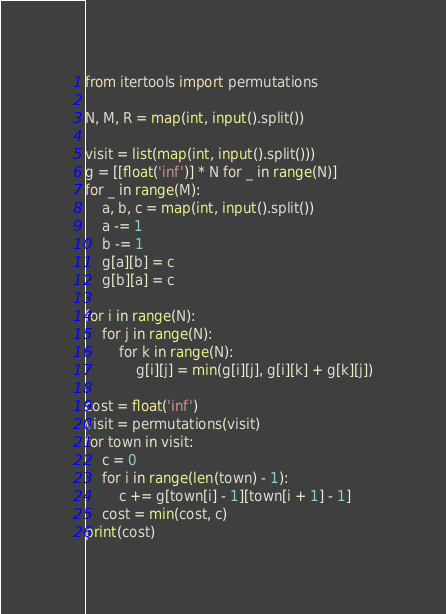<code> <loc_0><loc_0><loc_500><loc_500><_Python_>from itertools import permutations

N, M, R = map(int, input().split())

visit = list(map(int, input().split()))
g = [[float('inf')] * N for _ in range(N)]
for _ in range(M):
    a, b, c = map(int, input().split())
    a -= 1
    b -= 1
    g[a][b] = c
    g[b][a] = c

for i in range(N):
    for j in range(N):
        for k in range(N):
            g[i][j] = min(g[i][j], g[i][k] + g[k][j])

cost = float('inf')
visit = permutations(visit)
for town in visit:
    c = 0
    for i in range(len(town) - 1):
        c += g[town[i] - 1][town[i + 1] - 1]
    cost = min(cost, c)
print(cost)
</code> 